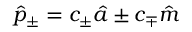Convert formula to latex. <formula><loc_0><loc_0><loc_500><loc_500>\hat { p } _ { \pm } = c _ { \pm } \hat { a } \pm c _ { \mp } \hat { m }</formula> 